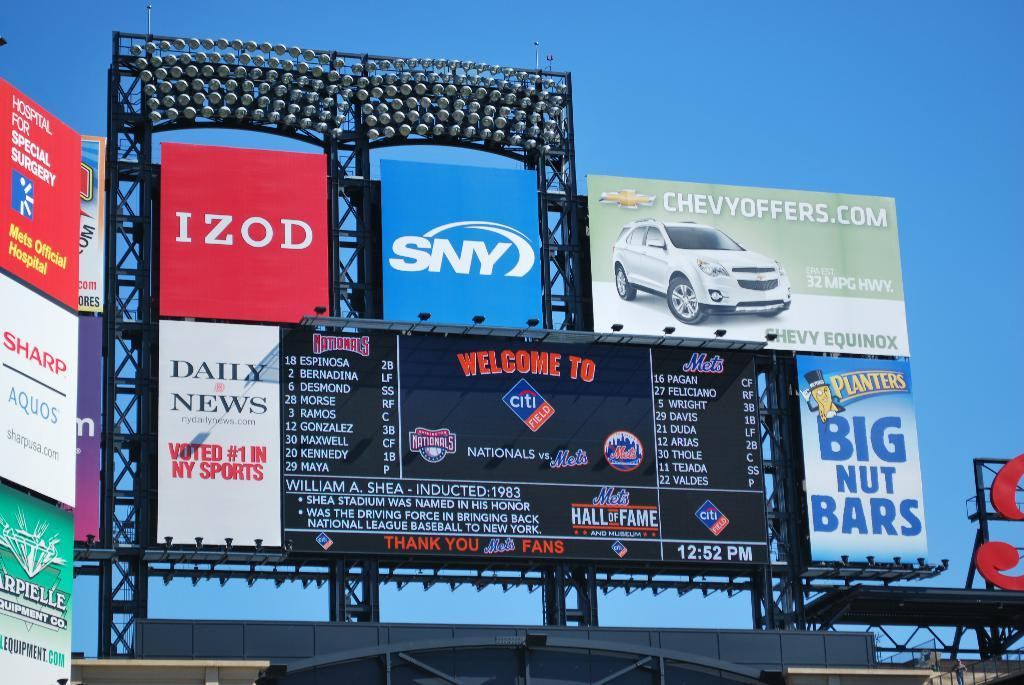<image>
Relay a brief, clear account of the picture shown. Scoreboard showing many ads including one for Planters peanuts. 